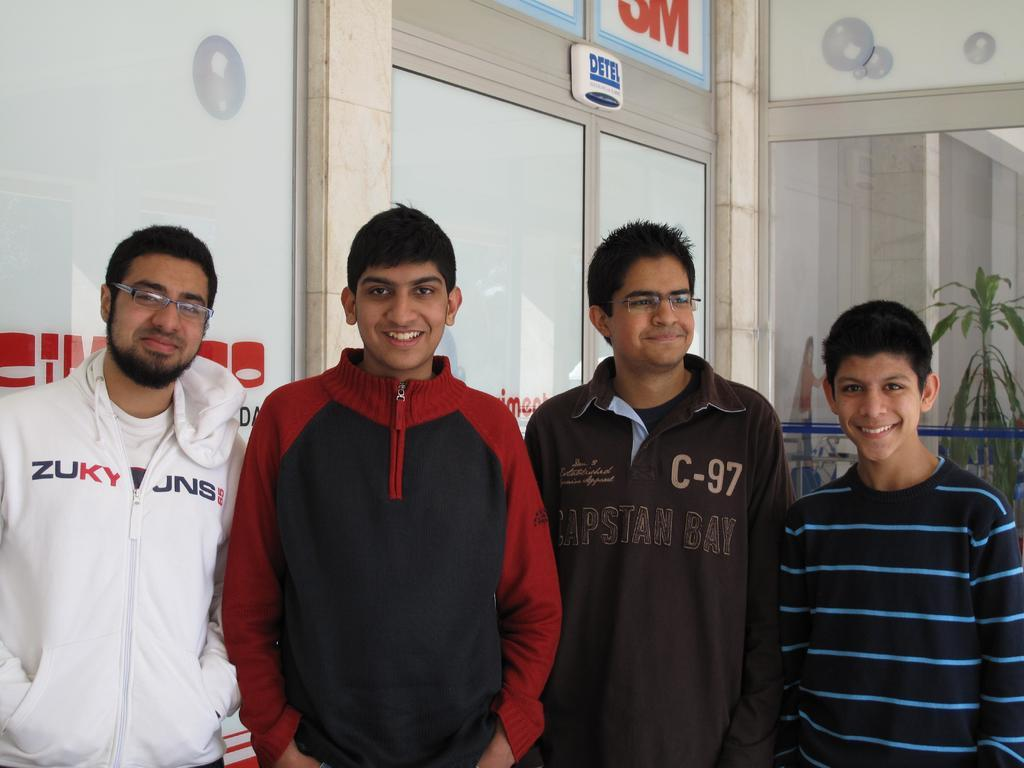<image>
Summarize the visual content of the image. A bearded man wearing a Zuky sweatshirt is standing in front of a storefront with three younger men. 